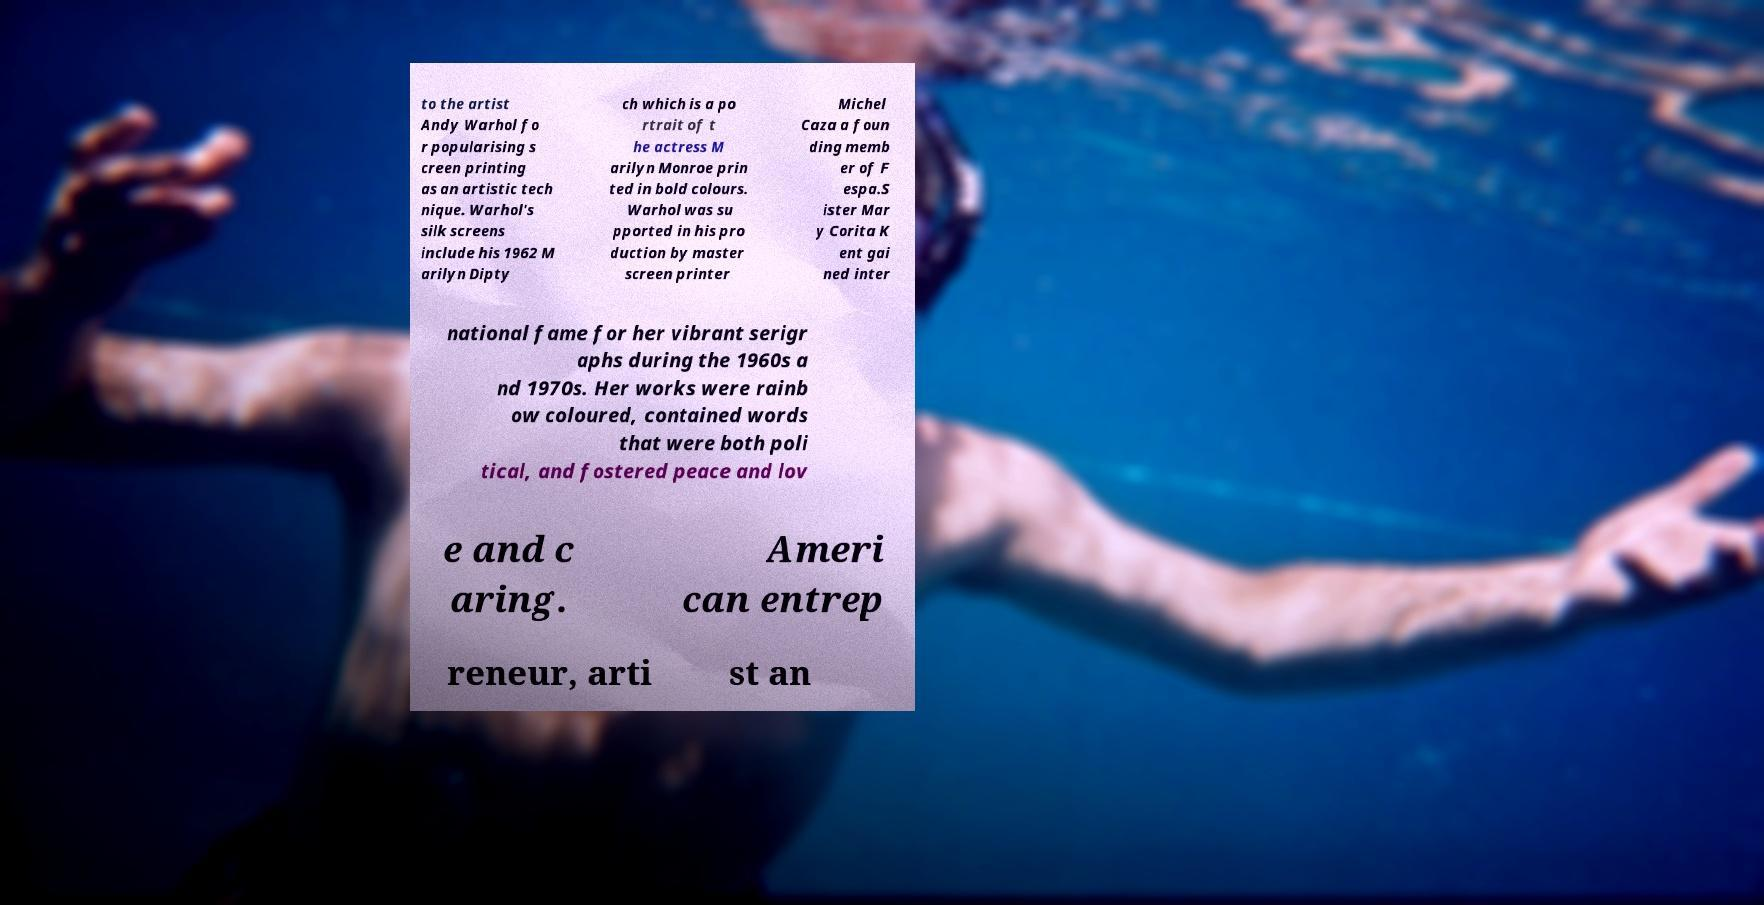For documentation purposes, I need the text within this image transcribed. Could you provide that? to the artist Andy Warhol fo r popularising s creen printing as an artistic tech nique. Warhol's silk screens include his 1962 M arilyn Dipty ch which is a po rtrait of t he actress M arilyn Monroe prin ted in bold colours. Warhol was su pported in his pro duction by master screen printer Michel Caza a foun ding memb er of F espa.S ister Mar y Corita K ent gai ned inter national fame for her vibrant serigr aphs during the 1960s a nd 1970s. Her works were rainb ow coloured, contained words that were both poli tical, and fostered peace and lov e and c aring. Ameri can entrep reneur, arti st an 